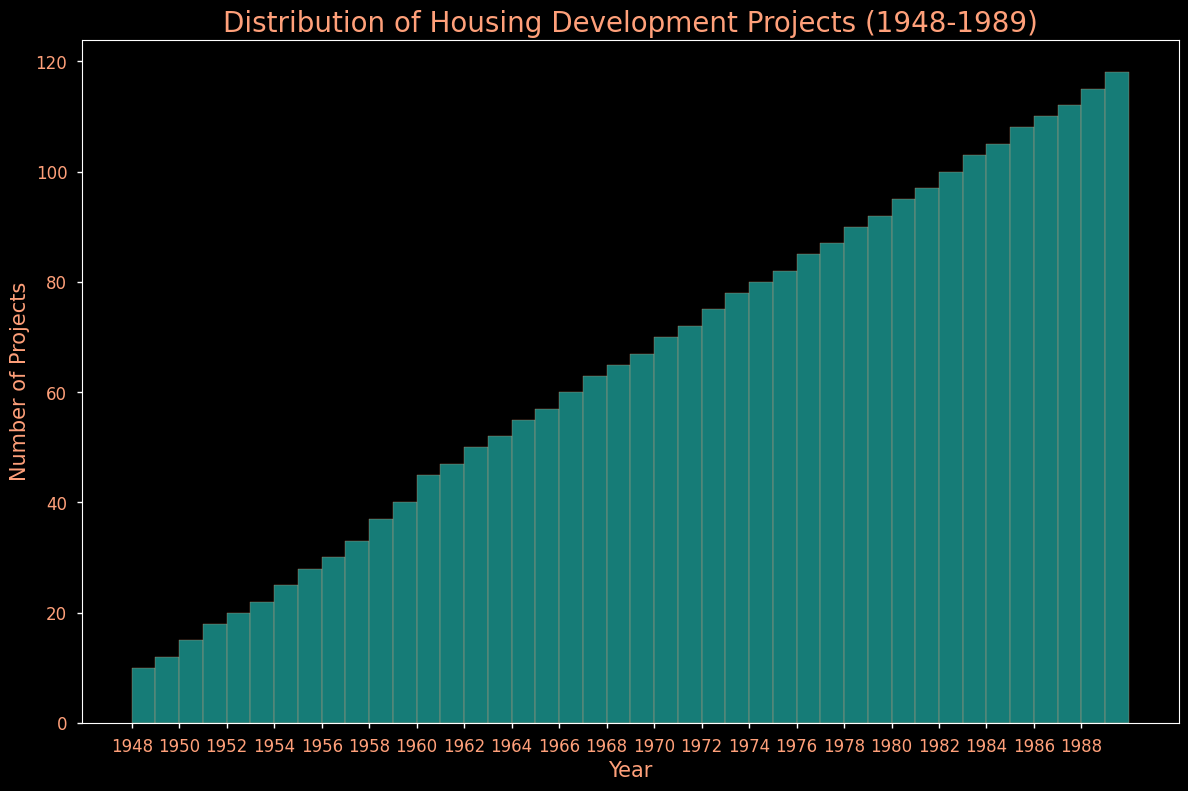What is the total number of housing development projects initiated in the 1950s? First, identify the bars in the histogram representing the years 1950-1959. Sum the values represented by each of these bars: 15+18+20+22+25+28+30+33+37+40. Thus, the total is 268.
Answer: 268 How does the number of housing development projects in 1989 compare to 1948? Locate the bars for the years 1989 and 1948. The bar for 1989 is significantly taller, indicating a higher number of projects. Specifically, 118 projects in 1989 compared to 10 in 1948.
Answer: 118 is greater than 10 What is the average number of housing development projects per year during the 1960s? Sum the projects from 1960 to 1969: 45+47+50+52+55+57+60+63+65+67, which totals 561. Divide this sum by 10 (the number of years) to find the average. The calculation is 561/10 which equals 56.1.
Answer: 56.1 Which year had the highest number of housing development projects? Identify the tallest bar in the histogram, which corresponds to the year 1989 with 118 projects.
Answer: 1989 By how much did the number of projects increase from 1970 to 1980? Identify the bars for 1970 (70 projects) and 1980 (95 projects). The difference between these years is 95 - 70, which equals 25.
Answer: 25 What is the trend in the number of housing development projects from 1948 to 1989? Observe the general shape of the histogram. The bars progressively increase in height, indicating a steady and consistent increase in the number of projects over the years.
Answer: Increasing trend During which decade did the largest absolute increase in the number of projects occur? Calculate the difference in the number of projects between the starting and ending years of each decade: 1948-1959 (40-10=30), 1960-1969 (67-45=22), 1970-1979 (92-70=22), 1980-1989 (118-95=23). The largest increase occurred in the 1948-1959 decade with an increase of 30.
Answer: 1950s Are there more projects in the first half or the second half of the entire period (1948-1968 vs. 1969-1989)? Sum the number of projects from 1948 to 1968 (inclusive): 10+12+15+18+20+22+25+28+30+33+37+40+45+47+50+52+55+57+60+63+65, which gives 716. Sum the projects from 1969 to 1989: 67+70+72+75+78+80+82+85+87+90+92+95+97+100+103+105+108+110+112+115+118, which totals 2063. Thus, the second half has significantly more projects.
Answer: Second half What is the average yearly increase in housing development projects from 1948 to 1989? Calculate the total increase over the period: 118 (1989) - 10 (1948) = 108. There are 41 years between 1948 and 1989. Divide the total increase by the number of years to find the average yearly increase: 108/41 is approximately 2.63.
Answer: 2.63 How many more housing development projects were there in 1985 compared to 1955? Find the bars for 1985 (108 projects) and 1955 (28 projects). Subtract the 1955 value from the 1985 value: 108 - 28 = 80.
Answer: 80 